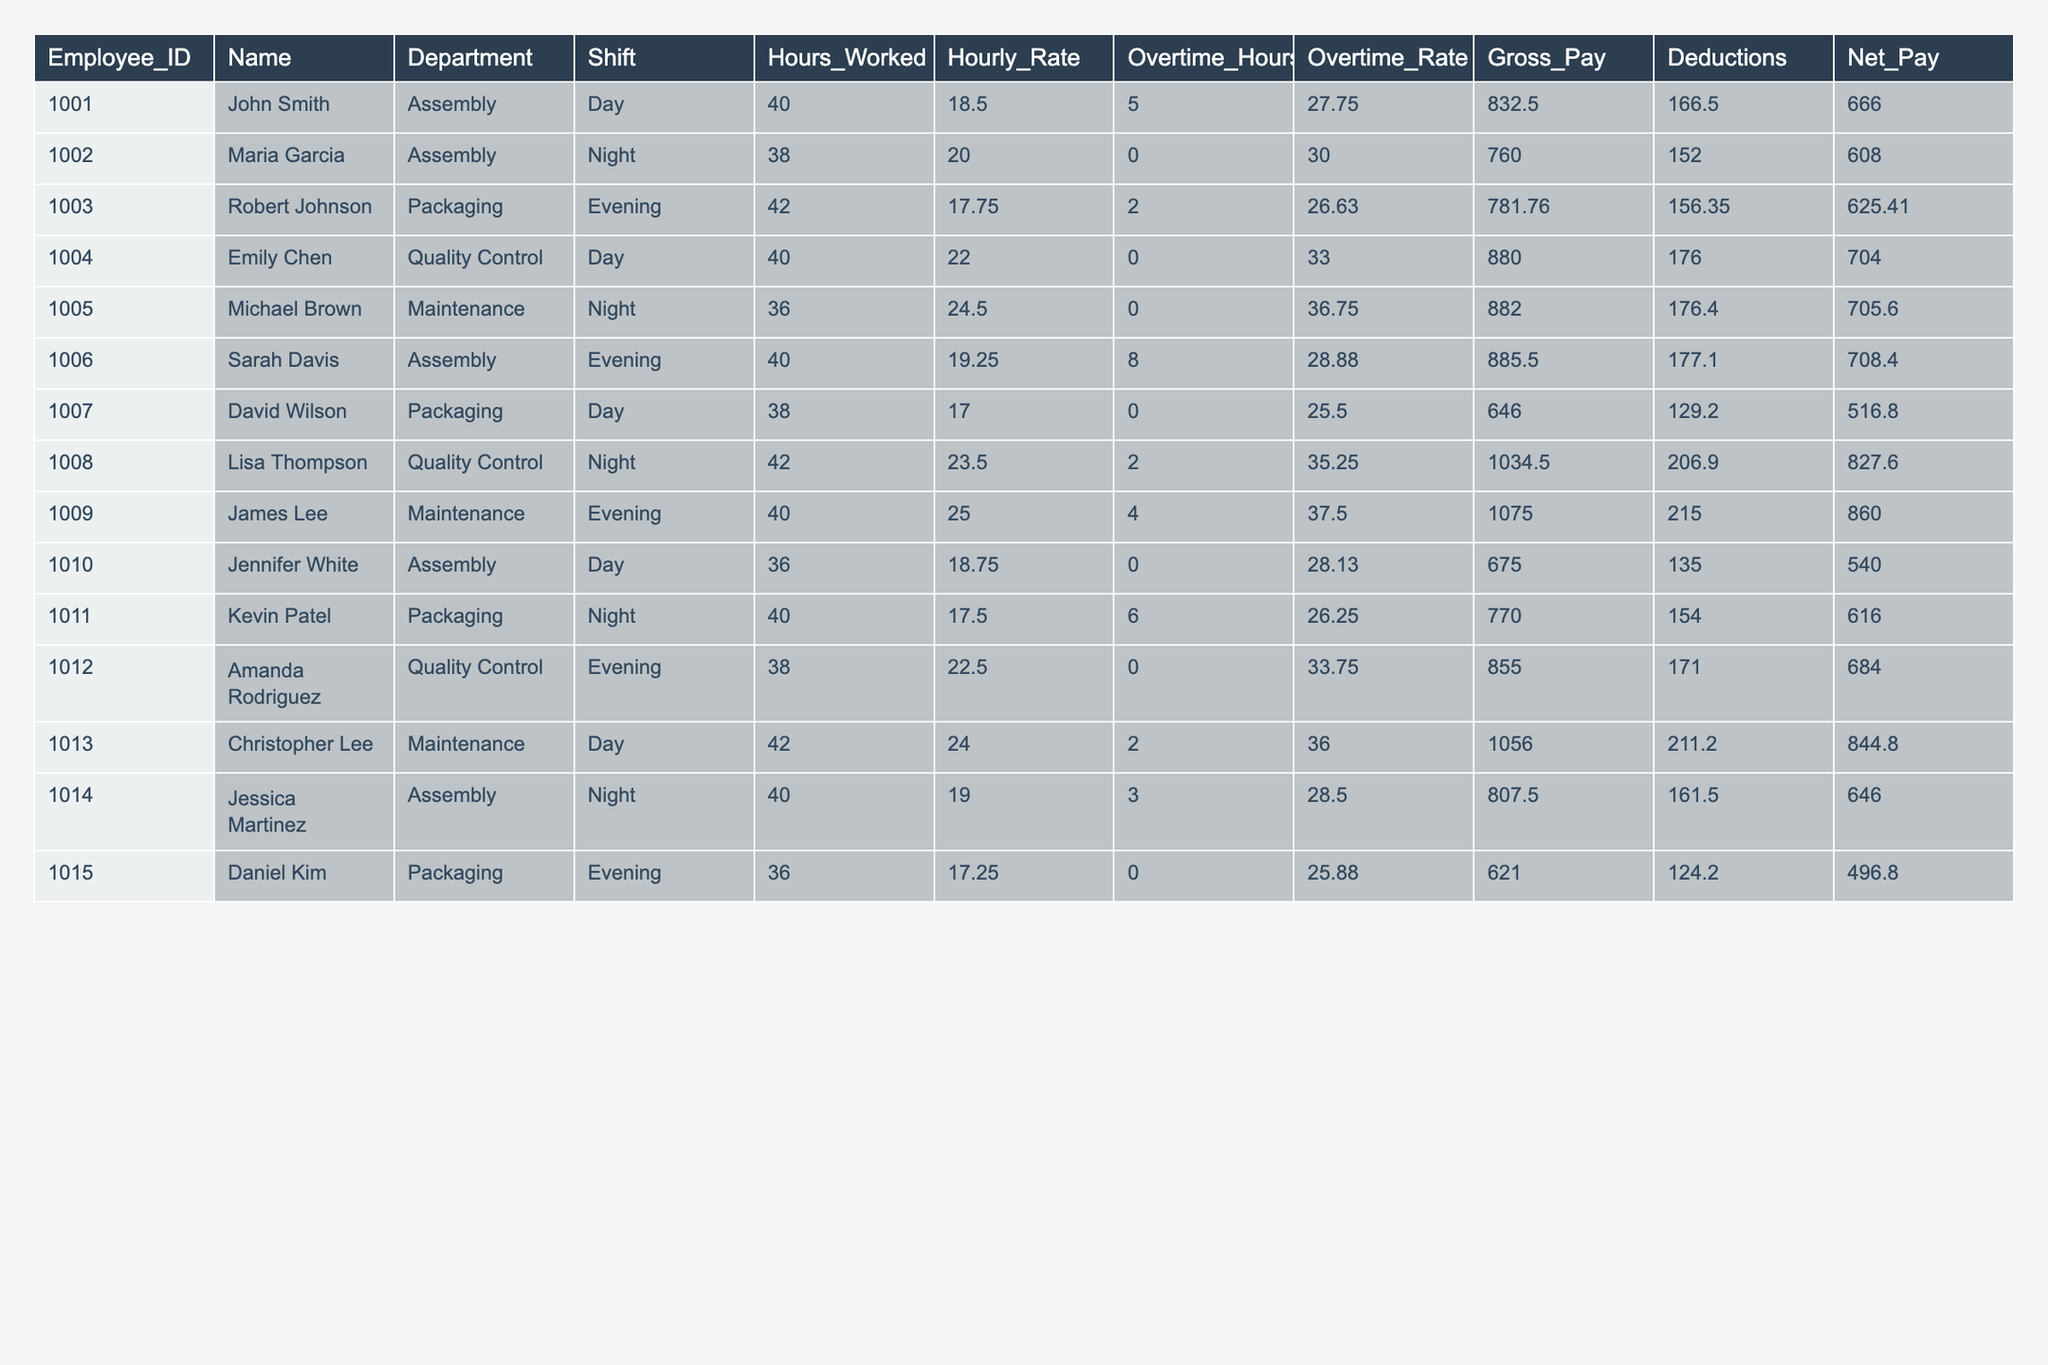What is the Gross Pay of Michael Brown? In the table, I can find the row for Michael Brown, who has an Employee_ID of 1005. The Gross Pay listed under this row is 882.00.
Answer: 882.00 Who worked the most hours in a Day shift? The table has multiple employees working Day shifts, including John Smith, Emily Chen, and Kevin Patel. Among them, John Smith worked 40 hours, Emily Chen worked 40 hours, and Kevin Patel worked 40 hours. So, they all have the maximum hours at 40.
Answer: 40 hours How many employees worked the Night shift? Counting the rows in the table that have the Night shift, there are 5 employees: Maria Garcia, Michael Brown, Lisa Thompson, Kevin Patel, and Jessica Martinez.
Answer: 5 What is the total Gross Pay for all employees in the Packaging department? First, I identify the employees in the Packaging department: Robert Johnson, David Wilson, and Daniel Kim. Their Gross Pay amounts are 781.76, 646.00, and 621.00, respectively. Adding these gives 781.76 + 646.00 + 621.00 = 2048.76.
Answer: 2048.76 Does Sarah Davis have a higher Net Pay than David Wilson? Sarah Davis has a Net Pay of 708.40, while David Wilson’s Net Pay is 516.80. Since 708.40 > 516.80, it confirms that Sarah Davis has a higher Net Pay.
Answer: Yes What is the average Hourly Rate for employees working the Evening shift? The Evening shift workers are Robert Johnson, Sarah Davis, and Daniel Kim. Their Hourly Rates are 17.75, 19.25, and 17.25, respectively. I sum these to get 17.75 + 19.25 + 17.25 = 54.25, and divide by 3 to find the average: 54.25 / 3 = 18.08.
Answer: 18.08 Which employee received the least deductions? Looking through the Deductions column, it shows that Daniel Kim has the lowest deduction of 124.20.
Answer: 124.20 What is the total Overtime Pay for all employees? I will calculate Overtime Pay by summing (Overtime Hours * Overtime Rate) for each employee. The totals are: John Smith (5*27.75=138.75), Maria Garcia (0=0), Robert Johnson (2*26.63=53.26), etc. totaling gives 138.75+0+53.26+0+0+231.04+0+70.50+150.00+0+157.50+0+72.00+97.50=826.55.
Answer: 826.55 What is the Net Pay of the employee with the highest Hourly Rate? The highest Hourly Rate among employees is 25.00 for James Lee. His Net Pay displayed in the table is 860.00.
Answer: 860.00 How many employees have a Net Pay greater than 700? By checking the Net Pay column, John Smith, Emily Chen, Sarah Davis, Lisa Thompson, James Lee, and Christopher Lee have Net Pays greater than 700. Counting these gives a total of 6 employees.
Answer: 6 